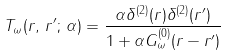<formula> <loc_0><loc_0><loc_500><loc_500>T _ { \omega } ( { r } , \, { r } ^ { \prime } ; \, \alpha ) = \frac { \alpha \delta ^ { ( 2 ) } ( { r } ) \delta ^ { ( 2 ) } ( { r } ^ { \prime } ) } { 1 + \alpha G ^ { ( 0 ) } _ { \omega } ( { r } - { r } ^ { \prime } ) }</formula> 